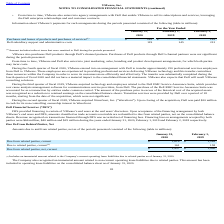According to Vmware's financial document, What did the current amounts due to related parties include? an immaterial amount related to the Company’s current operating lease liabilities due to related parties as of January 31, 2020.. The document states: "(1) Includes an immaterial amount related to the Company’s current operating lease liabilities due to related parties as of January 31, 2020...." Also, What was the current amount due from related parties in 2019? According to the financial document, 1,248 (in millions). The relevant text states: "Due from related parties, current $ 1,618 $ 1,248..." Also, Which years does the table provide information for net Amounts due to and from related parties? The document shows two values: 2020 and 2019. From the document: "2020 2019 2018 2020 2019 2018..." Also, How many years did current amount due from related parties exceed $1,000 million? Counting the relevant items in the document: 2020, 2019, I find 2 instances. The key data points involved are: 2019, 2020. Also, can you calculate: What was the change in current amount due to related parties between 2019 and 2020? Based on the calculation: 161-158, the result is 3 (in millions). This is based on the information: "Due to related parties, current (1) 161 158 Due to related parties, current (1) 161 158..." The key data points involved are: 158, 161. Also, can you calculate: What was the percentage change in the net current amount due from related parities between 2019 and 2020? To answer this question, I need to perform calculations using the financial data. The calculation is: (1,457-1,090)/1,090, which equals 33.67 (percentage). This is based on the information: "Due from related parties, net, current $ 1,457 $ 1,090 Due from related parties, net, current $ 1,457 $ 1,090..." The key data points involved are: 1,090, 1,457. 